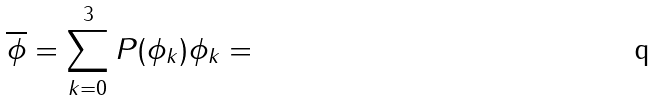<formula> <loc_0><loc_0><loc_500><loc_500>\overline { \phi } = \sum _ { k = 0 } ^ { 3 } P ( \phi _ { k } ) \phi _ { k } =</formula> 